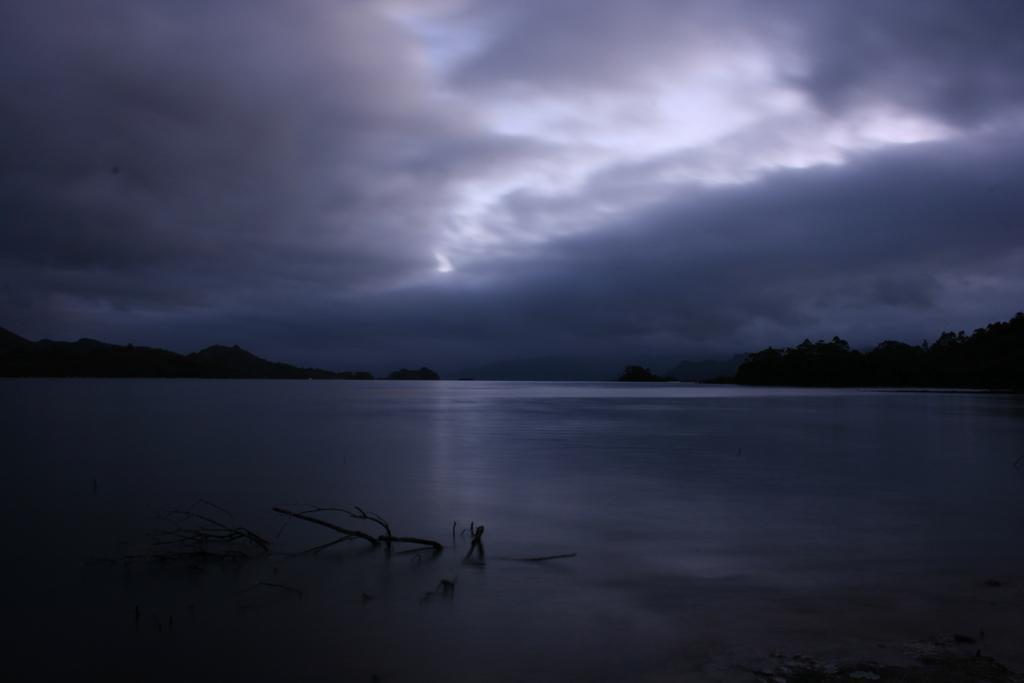Please provide a concise description of this image. In this image we can see sky with clouds, trees and water. 